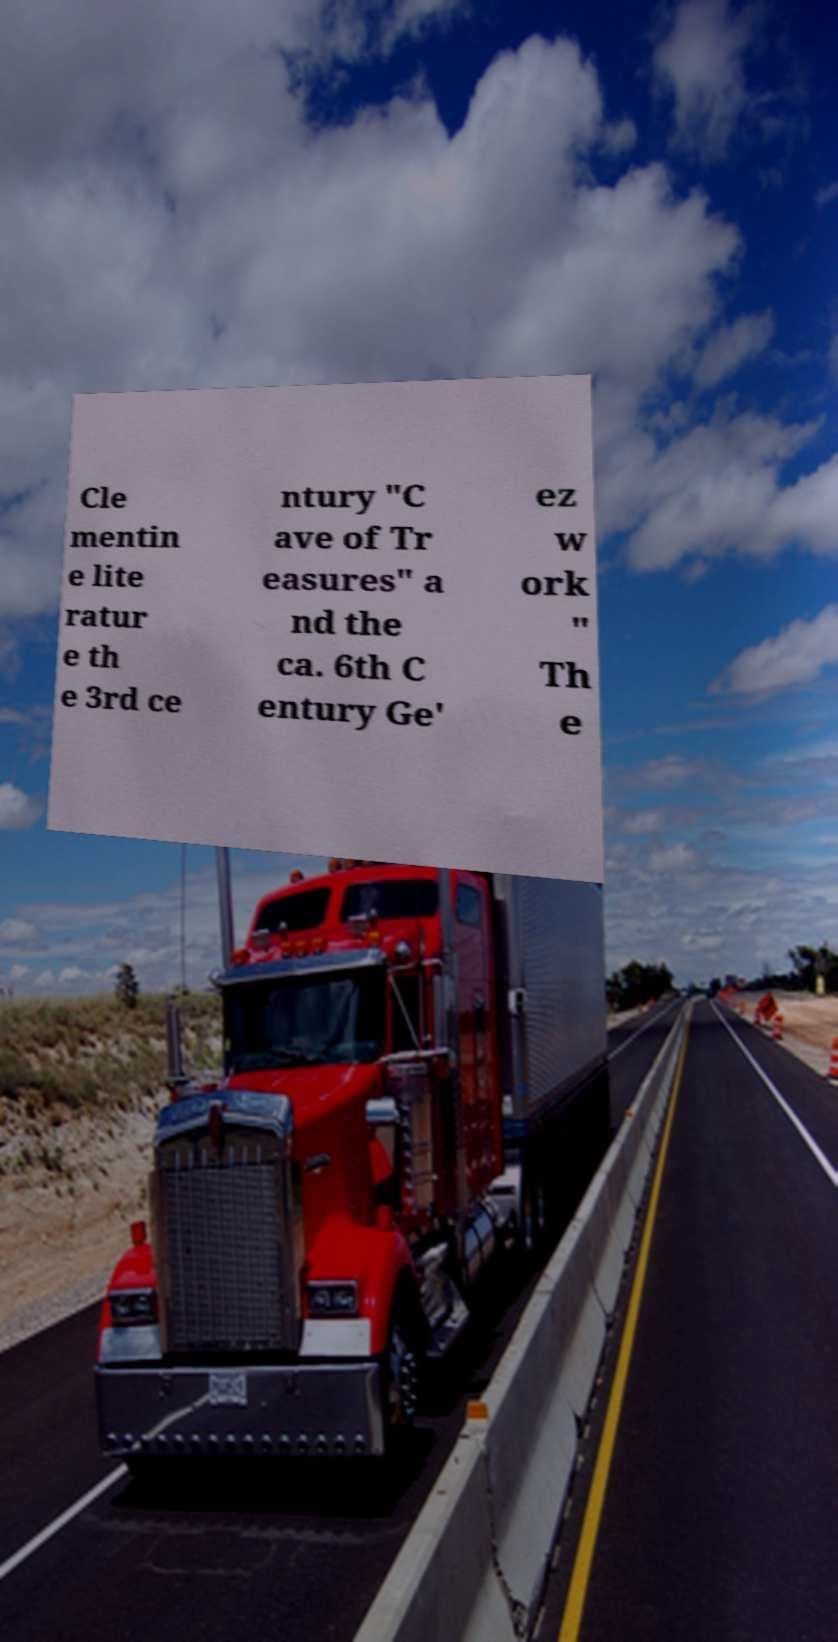Could you extract and type out the text from this image? Cle mentin e lite ratur e th e 3rd ce ntury "C ave of Tr easures" a nd the ca. 6th C entury Ge' ez w ork " Th e 